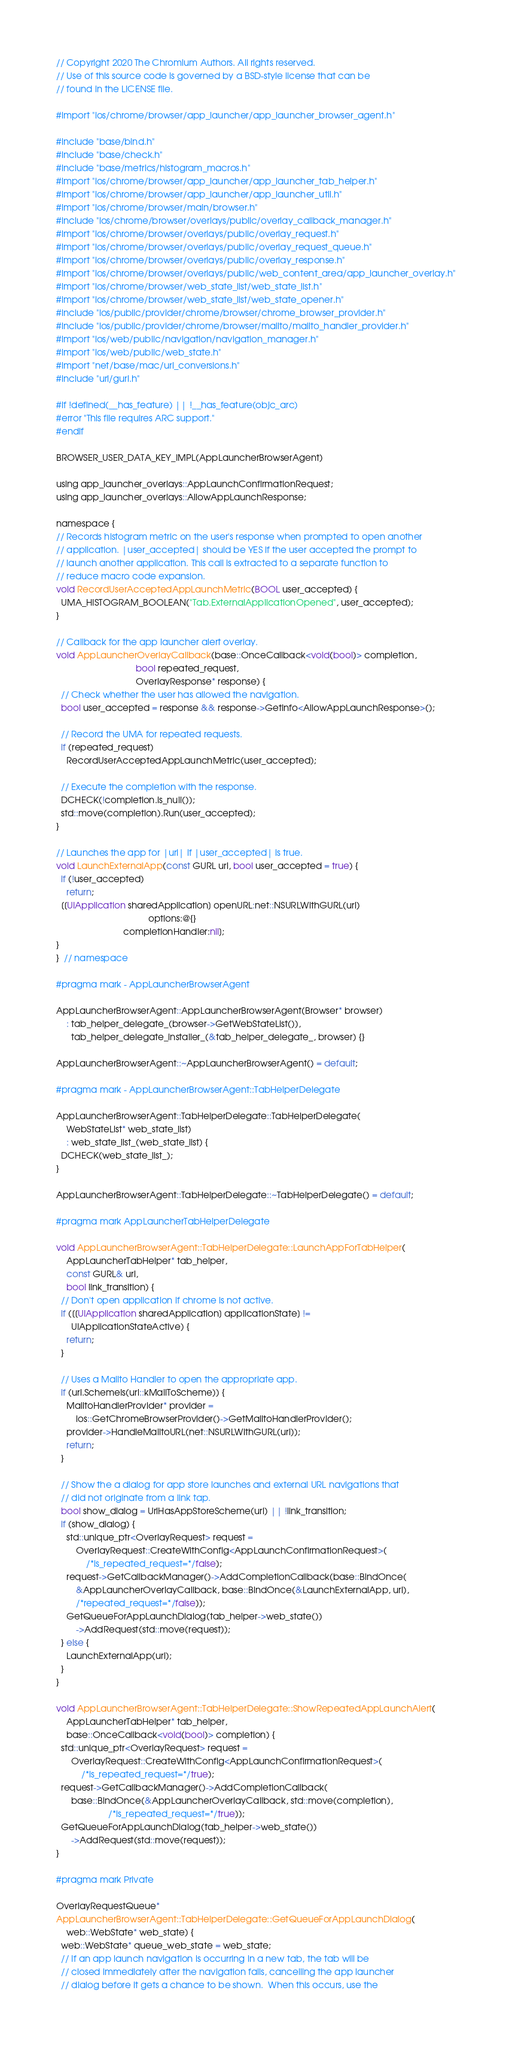Convert code to text. <code><loc_0><loc_0><loc_500><loc_500><_ObjectiveC_>// Copyright 2020 The Chromium Authors. All rights reserved.
// Use of this source code is governed by a BSD-style license that can be
// found in the LICENSE file.

#import "ios/chrome/browser/app_launcher/app_launcher_browser_agent.h"

#include "base/bind.h"
#include "base/check.h"
#include "base/metrics/histogram_macros.h"
#import "ios/chrome/browser/app_launcher/app_launcher_tab_helper.h"
#import "ios/chrome/browser/app_launcher/app_launcher_util.h"
#import "ios/chrome/browser/main/browser.h"
#include "ios/chrome/browser/overlays/public/overlay_callback_manager.h"
#import "ios/chrome/browser/overlays/public/overlay_request.h"
#import "ios/chrome/browser/overlays/public/overlay_request_queue.h"
#import "ios/chrome/browser/overlays/public/overlay_response.h"
#import "ios/chrome/browser/overlays/public/web_content_area/app_launcher_overlay.h"
#import "ios/chrome/browser/web_state_list/web_state_list.h"
#import "ios/chrome/browser/web_state_list/web_state_opener.h"
#include "ios/public/provider/chrome/browser/chrome_browser_provider.h"
#include "ios/public/provider/chrome/browser/mailto/mailto_handler_provider.h"
#import "ios/web/public/navigation/navigation_manager.h"
#import "ios/web/public/web_state.h"
#import "net/base/mac/url_conversions.h"
#include "url/gurl.h"

#if !defined(__has_feature) || !__has_feature(objc_arc)
#error "This file requires ARC support."
#endif

BROWSER_USER_DATA_KEY_IMPL(AppLauncherBrowserAgent)

using app_launcher_overlays::AppLaunchConfirmationRequest;
using app_launcher_overlays::AllowAppLaunchResponse;

namespace {
// Records histogram metric on the user's response when prompted to open another
// application. |user_accepted| should be YES if the user accepted the prompt to
// launch another application. This call is extracted to a separate function to
// reduce macro code expansion.
void RecordUserAcceptedAppLaunchMetric(BOOL user_accepted) {
  UMA_HISTOGRAM_BOOLEAN("Tab.ExternalApplicationOpened", user_accepted);
}

// Callback for the app launcher alert overlay.
void AppLauncherOverlayCallback(base::OnceCallback<void(bool)> completion,
                                bool repeated_request,
                                OverlayResponse* response) {
  // Check whether the user has allowed the navigation.
  bool user_accepted = response && response->GetInfo<AllowAppLaunchResponse>();

  // Record the UMA for repeated requests.
  if (repeated_request)
    RecordUserAcceptedAppLaunchMetric(user_accepted);

  // Execute the completion with the response.
  DCHECK(!completion.is_null());
  std::move(completion).Run(user_accepted);
}

// Launches the app for |url| if |user_accepted| is true.
void LaunchExternalApp(const GURL url, bool user_accepted = true) {
  if (!user_accepted)
    return;
  [[UIApplication sharedApplication] openURL:net::NSURLWithGURL(url)
                                     options:@{}
                           completionHandler:nil];
}
}  // namespace

#pragma mark - AppLauncherBrowserAgent

AppLauncherBrowserAgent::AppLauncherBrowserAgent(Browser* browser)
    : tab_helper_delegate_(browser->GetWebStateList()),
      tab_helper_delegate_installer_(&tab_helper_delegate_, browser) {}

AppLauncherBrowserAgent::~AppLauncherBrowserAgent() = default;

#pragma mark - AppLauncherBrowserAgent::TabHelperDelegate

AppLauncherBrowserAgent::TabHelperDelegate::TabHelperDelegate(
    WebStateList* web_state_list)
    : web_state_list_(web_state_list) {
  DCHECK(web_state_list_);
}

AppLauncherBrowserAgent::TabHelperDelegate::~TabHelperDelegate() = default;

#pragma mark AppLauncherTabHelperDelegate

void AppLauncherBrowserAgent::TabHelperDelegate::LaunchAppForTabHelper(
    AppLauncherTabHelper* tab_helper,
    const GURL& url,
    bool link_transition) {
  // Don't open application if chrome is not active.
  if ([[UIApplication sharedApplication] applicationState] !=
      UIApplicationStateActive) {
    return;
  }

  // Uses a Mailto Handler to open the appropriate app.
  if (url.SchemeIs(url::kMailToScheme)) {
    MailtoHandlerProvider* provider =
        ios::GetChromeBrowserProvider()->GetMailtoHandlerProvider();
    provider->HandleMailtoURL(net::NSURLWithGURL(url));
    return;
  }

  // Show the a dialog for app store launches and external URL navigations that
  // did not originate from a link tap.
  bool show_dialog = UrlHasAppStoreScheme(url) || !link_transition;
  if (show_dialog) {
    std::unique_ptr<OverlayRequest> request =
        OverlayRequest::CreateWithConfig<AppLaunchConfirmationRequest>(
            /*is_repeated_request=*/false);
    request->GetCallbackManager()->AddCompletionCallback(base::BindOnce(
        &AppLauncherOverlayCallback, base::BindOnce(&LaunchExternalApp, url),
        /*repeated_request=*/false));
    GetQueueForAppLaunchDialog(tab_helper->web_state())
        ->AddRequest(std::move(request));
  } else {
    LaunchExternalApp(url);
  }
}

void AppLauncherBrowserAgent::TabHelperDelegate::ShowRepeatedAppLaunchAlert(
    AppLauncherTabHelper* tab_helper,
    base::OnceCallback<void(bool)> completion) {
  std::unique_ptr<OverlayRequest> request =
      OverlayRequest::CreateWithConfig<AppLaunchConfirmationRequest>(
          /*is_repeated_request=*/true);
  request->GetCallbackManager()->AddCompletionCallback(
      base::BindOnce(&AppLauncherOverlayCallback, std::move(completion),
                     /*is_repeated_request=*/true));
  GetQueueForAppLaunchDialog(tab_helper->web_state())
      ->AddRequest(std::move(request));
}

#pragma mark Private

OverlayRequestQueue*
AppLauncherBrowserAgent::TabHelperDelegate::GetQueueForAppLaunchDialog(
    web::WebState* web_state) {
  web::WebState* queue_web_state = web_state;
  // If an app launch navigation is occurring in a new tab, the tab will be
  // closed immediately after the navigation fails, cancelling the app launcher
  // dialog before it gets a chance to be shown.  When this occurs, use the</code> 